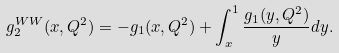Convert formula to latex. <formula><loc_0><loc_0><loc_500><loc_500>g _ { 2 } ^ { W W } ( x , Q ^ { 2 } ) = - g _ { 1 } ( x , Q ^ { 2 } ) + \int _ { x } ^ { 1 } \frac { g _ { 1 } ( y , Q ^ { 2 } ) } { y } d y .</formula> 